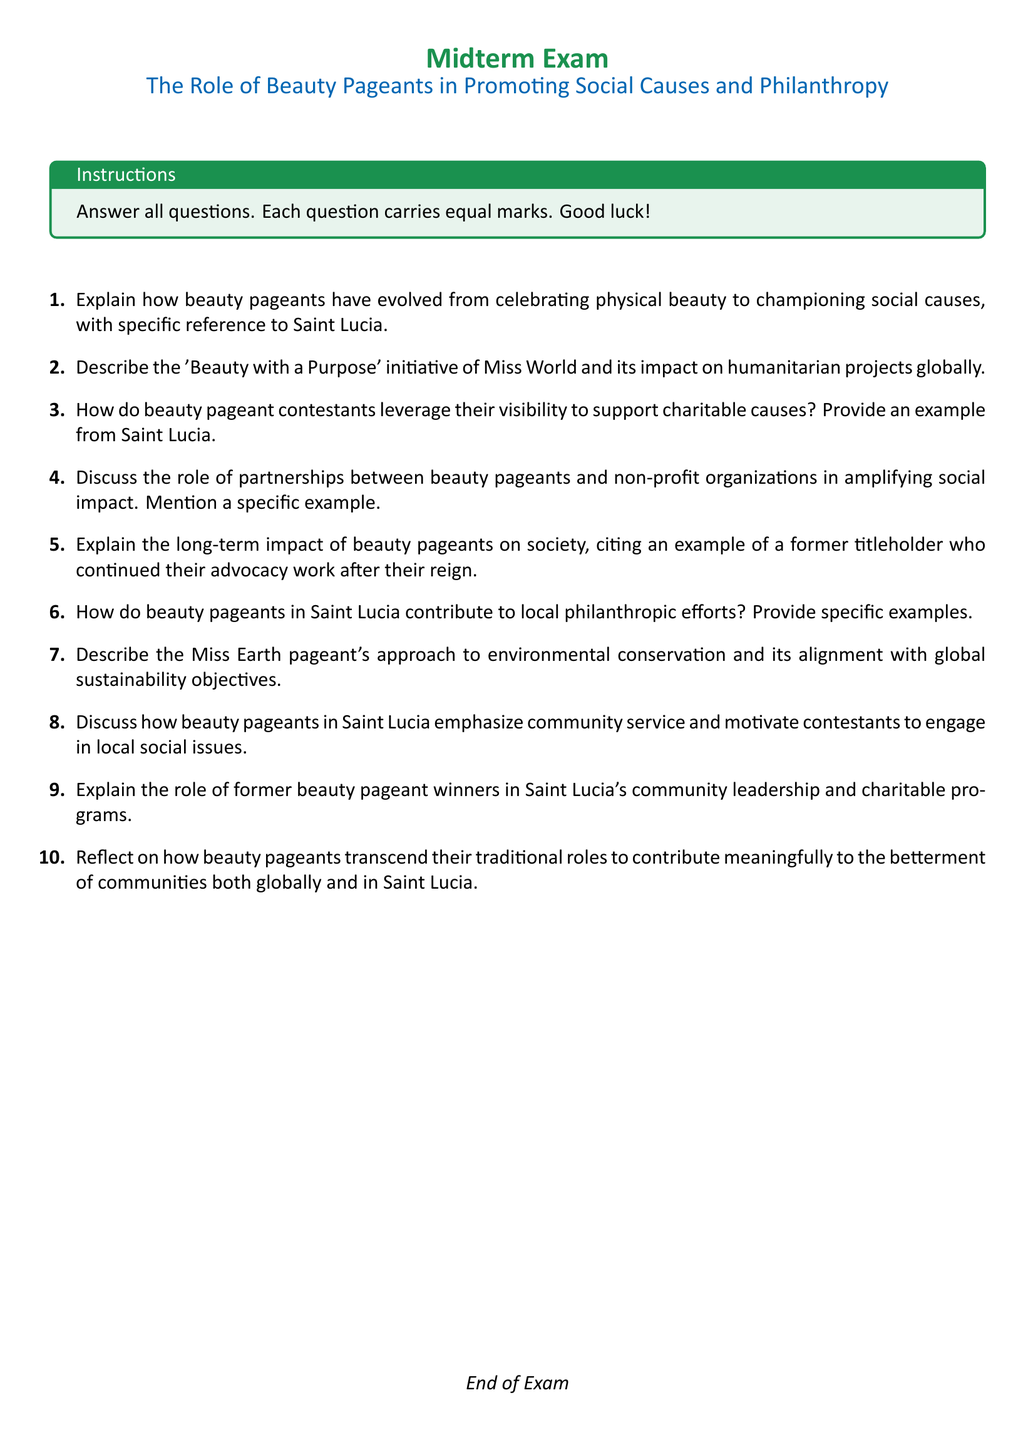What is the title of the midterm exam? The title is found in the header section of the document, stating, "The Role of Beauty Pageants in Promoting Social Causes and Philanthropy."
Answer: The Role of Beauty Pageants in Promoting Social Causes and Philanthropy How many questions are there in the exam? The document lists a total of ten questions for the exam.
Answer: 10 What initiative is mentioned in relation to Miss World? The document specifies the initiative as "Beauty with a Purpose."
Answer: Beauty with a Purpose Which pageant focuses on environmental conservation? The document mentions "Miss Earth" as the pageant that has an approach to environmental conservation.
Answer: Miss Earth Who is asked to reflect on beauty pageants' contributions? The document prompts the examination participants to think about the general role of beauty pageants, meaning it refers to the contestants or students among others.
Answer: contestants What color is used for the page headings? The document indicates that the headings are colored with "saintluciagreen."
Answer: saintluciagreen What is the purpose of the tcolorbox in the document? The tcolorbox is used to provide instructions to the participants regarding the exam format, which includes answering all questions.
Answer: Instructions Which local aspect is specifically addressed in the exam? The document highlights "local philanthropic efforts" in the context of beauty pageants in Saint Lucia.
Answer: local philanthropic efforts What is requested from contestants in terms of community engagement? Contestants are prompted to engage in "local social issues," emphasizing community service.
Answer: local social issues 